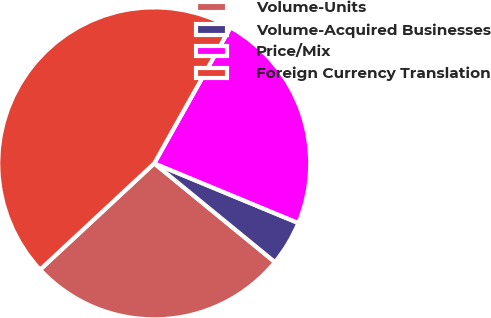Convert chart. <chart><loc_0><loc_0><loc_500><loc_500><pie_chart><fcel>Volume-Units<fcel>Volume-Acquired Businesses<fcel>Price/Mix<fcel>Foreign Currency Translation<nl><fcel>27.15%<fcel>4.67%<fcel>23.11%<fcel>45.06%<nl></chart> 